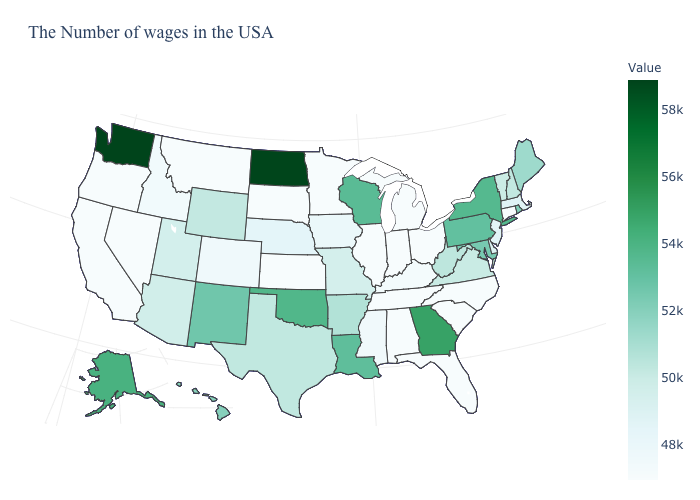Is the legend a continuous bar?
Answer briefly. Yes. Does Nevada have the lowest value in the West?
Be succinct. Yes. Which states have the lowest value in the South?
Quick response, please. North Carolina, South Carolina, Florida, Alabama, Tennessee. Does Alaska have the highest value in the West?
Write a very short answer. No. Among the states that border Nevada , does Oregon have the lowest value?
Keep it brief. Yes. Among the states that border Arkansas , does Oklahoma have the lowest value?
Quick response, please. No. 